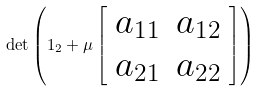Convert formula to latex. <formula><loc_0><loc_0><loc_500><loc_500>\det \left ( { 1 } _ { 2 } + \mu \left [ \begin{array} { c c } a _ { 1 1 } & a _ { 1 2 } \\ a _ { 2 1 } & a _ { 2 2 } \end{array} \right ] \right )</formula> 